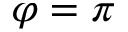<formula> <loc_0><loc_0><loc_500><loc_500>\varphi = \pi</formula> 